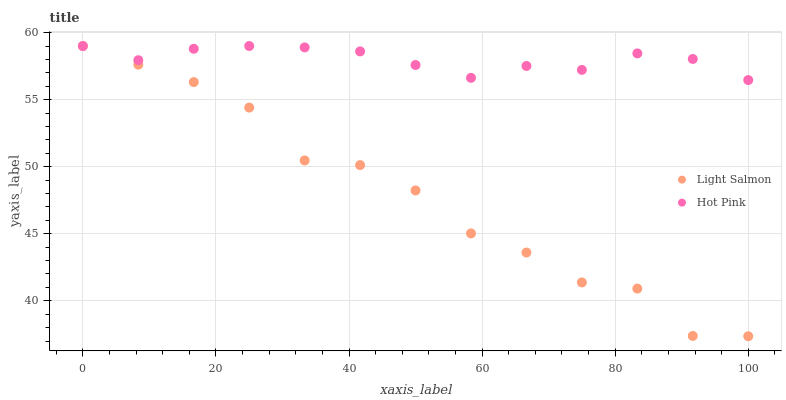Does Light Salmon have the minimum area under the curve?
Answer yes or no. Yes. Does Hot Pink have the maximum area under the curve?
Answer yes or no. Yes. Does Hot Pink have the minimum area under the curve?
Answer yes or no. No. Is Hot Pink the smoothest?
Answer yes or no. Yes. Is Light Salmon the roughest?
Answer yes or no. Yes. Is Hot Pink the roughest?
Answer yes or no. No. Does Light Salmon have the lowest value?
Answer yes or no. Yes. Does Hot Pink have the lowest value?
Answer yes or no. No. Does Hot Pink have the highest value?
Answer yes or no. Yes. Does Light Salmon intersect Hot Pink?
Answer yes or no. Yes. Is Light Salmon less than Hot Pink?
Answer yes or no. No. Is Light Salmon greater than Hot Pink?
Answer yes or no. No. 